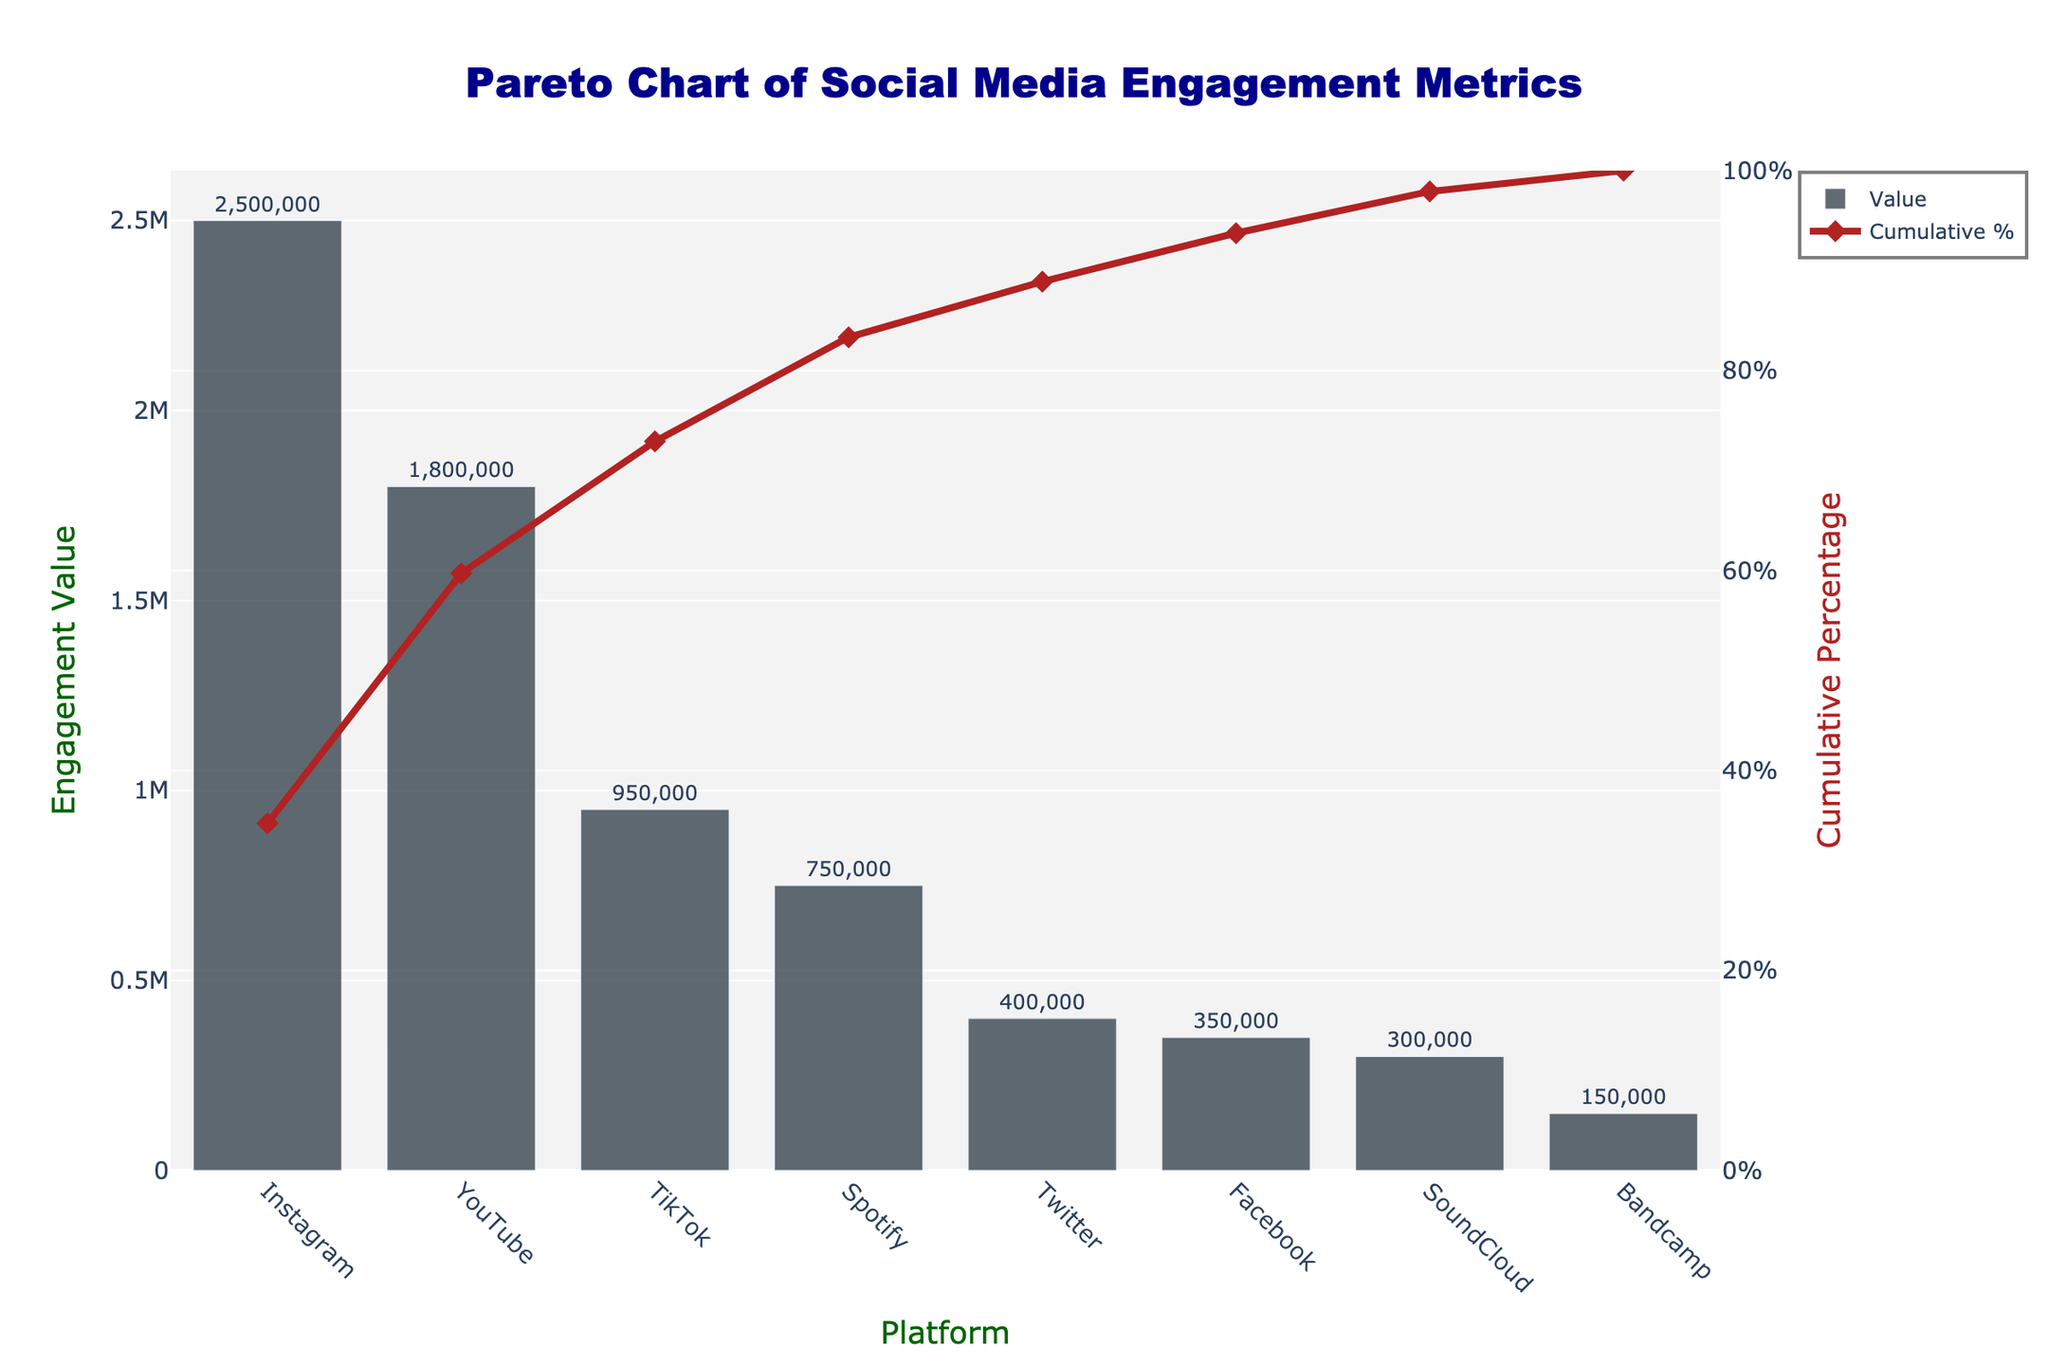what is the total engagement value depicted in the chart? The total engagement value is the sum of all values from different platforms. Adding up the values, we get (2500000 + 1800000 + 950000 + 750000 + 400000 + 350000 + 300000 + 150000) = 7000000.
Answer: 7000000 which platform has the highest engagement value? Looking at the bar heights, which represent engagement values, Instagram has the tallest bar with 2500000 engagement.
Answer: Instagram what percentage of total engagement does Instagram contribute? Instagram's contribution percentage is calculated as (engagement value of Instagram / total engagement) * 100%. So, (2500000 / 7000000) * 100% = approximately 35.71%.
Answer: 35.71% how much combined engagement value do TikTok and Twitter have? Adding values from TikTok and Twitter, we get (950000 + 400000) = 1350000.
Answer: 1350000 which platform has the lowest engagement value and what is it? The platform with the lowest engagement value can be identified by the shortest bar. Bandcamp has the lowest engagement value of 150000.
Answer: Bandcamp, 150000 how does YouTube's engagement compare to Spotify's engagement? Comparing the bar heights, YouTube has 1800000 engagement whereas Spotify has 750000 engagement. YouTube's engagement is greater.
Answer: YouTube has more what is the cumulative percentage of the top three platforms? Adding the cumulative percentages of Instagram, YouTube, and TikTok gives roughly (35.71% + 61.42% + 75.00%) = approximately 75%.
Answer: 75% how many platforms have an engagement value of more than 500000? By looking at the height of bars greater than 500000, we count Instagram, YouTube, TikTok, and Spotify, totaling 4 platforms.
Answer: 4 which platforms cumulatively contribute to at least 80% of the total engagement? By summing cumulative percentages, Instagram (35.71%), YouTube (61.42%), TikTok (75.00%), and Spotify (85.71%) reach at least 80%.
Answer: Instagram, YouTube, TikTok, Spotify what is the gap between the engagement value of Facebook and SoundCloud? Subtracting SoundCloud's engagement value from Facebook's gives (350000 - 300000) = 50000.
Answer: 50000 